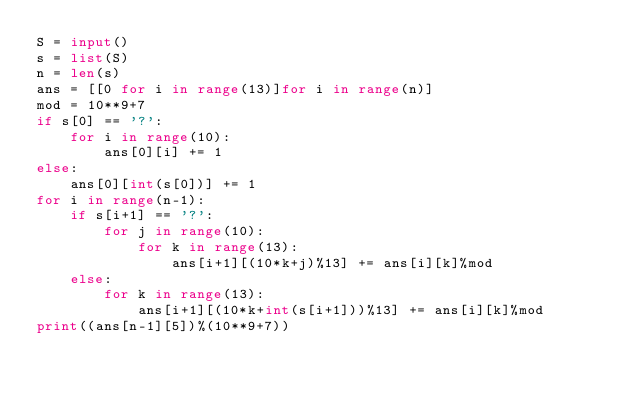<code> <loc_0><loc_0><loc_500><loc_500><_Python_>S = input()
s = list(S)
n = len(s)
ans = [[0 for i in range(13)]for i in range(n)]
mod = 10**9+7
if s[0] == '?':
    for i in range(10):
        ans[0][i] += 1
else:
    ans[0][int(s[0])] += 1
for i in range(n-1):
    if s[i+1] == '?':
        for j in range(10):
            for k in range(13):
                ans[i+1][(10*k+j)%13] += ans[i][k]%mod
    else:
        for k in range(13):
            ans[i+1][(10*k+int(s[i+1]))%13] += ans[i][k]%mod
print((ans[n-1][5])%(10**9+7))</code> 